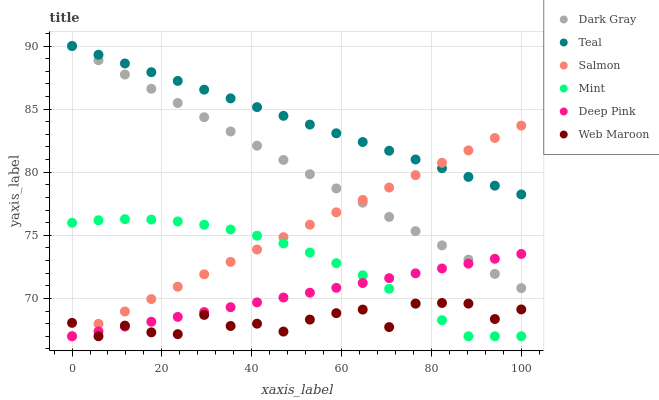Does Web Maroon have the minimum area under the curve?
Answer yes or no. Yes. Does Teal have the maximum area under the curve?
Answer yes or no. Yes. Does Salmon have the minimum area under the curve?
Answer yes or no. No. Does Salmon have the maximum area under the curve?
Answer yes or no. No. Is Dark Gray the smoothest?
Answer yes or no. Yes. Is Web Maroon the roughest?
Answer yes or no. Yes. Is Salmon the smoothest?
Answer yes or no. No. Is Salmon the roughest?
Answer yes or no. No. Does Deep Pink have the lowest value?
Answer yes or no. Yes. Does Dark Gray have the lowest value?
Answer yes or no. No. Does Teal have the highest value?
Answer yes or no. Yes. Does Salmon have the highest value?
Answer yes or no. No. Is Mint less than Teal?
Answer yes or no. Yes. Is Dark Gray greater than Mint?
Answer yes or no. Yes. Does Mint intersect Web Maroon?
Answer yes or no. Yes. Is Mint less than Web Maroon?
Answer yes or no. No. Is Mint greater than Web Maroon?
Answer yes or no. No. Does Mint intersect Teal?
Answer yes or no. No. 